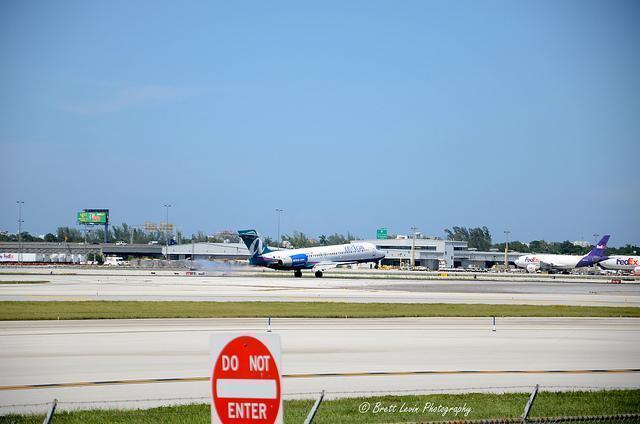What does the sign in front of the runways near the camera say?
Choose the correct response, then elucidate: 'Answer: answer
Rationale: rationale.'
Options: One way, stop, dead end, enter. Answer: enter.
Rationale: The sign at the airport in front of the runway says do not enter. What color is the FedEx airplane's tail fin?
Pick the correct solution from the four options below to address the question.
Options: Blue, green, yellow, purple. Purple. 